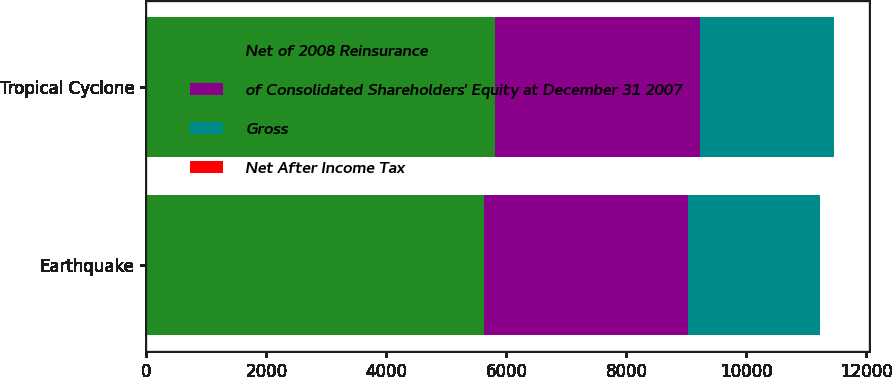Convert chart to OTSL. <chart><loc_0><loc_0><loc_500><loc_500><stacked_bar_chart><ecel><fcel>Earthquake<fcel>Tropical Cyclone<nl><fcel>Net of 2008 Reinsurance<fcel>5625<fcel>5802<nl><fcel>of Consolidated Shareholders' Equity at December 31 2007<fcel>3397<fcel>3430<nl><fcel>Gross<fcel>2208<fcel>2230<nl><fcel>Net After Income Tax<fcel>2.3<fcel>2.3<nl></chart> 